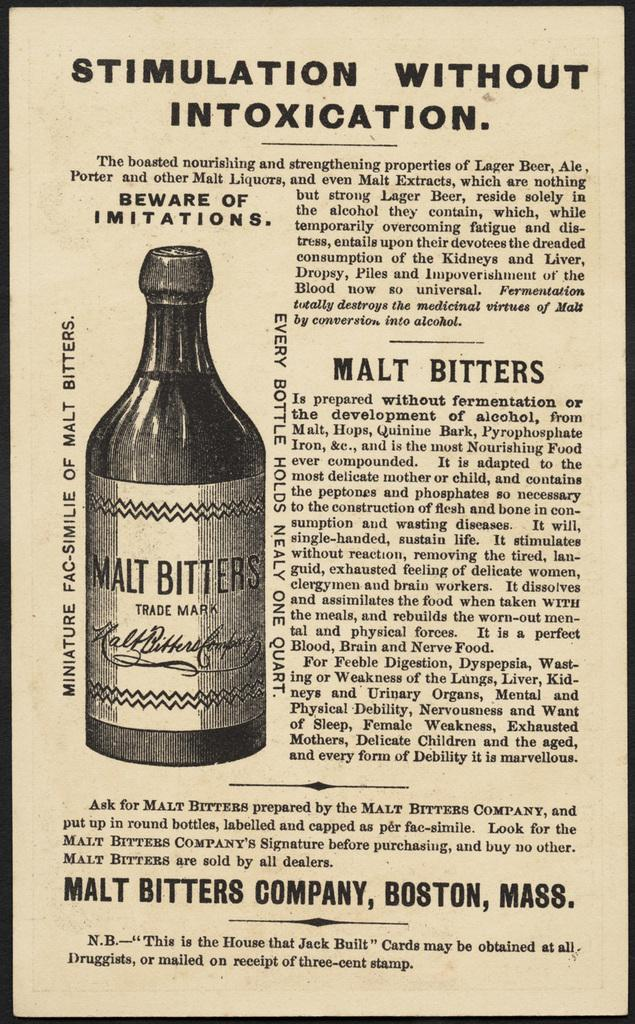What is the main object in the image? The image contains a pamphlet. What can be found on the pamphlet? There is text on the pamphlet. Is there any illustration on the pamphlet? Yes, there is a drawing of a bottle on the pamphlet. What is the title of the book shown in the image? There is no book present in the image, only a pamphlet. Can you see any smoke coming from the drawing of the bottle? There is no smoke present in the image, nor is there any indication of smoke in the drawing of the bottle. 